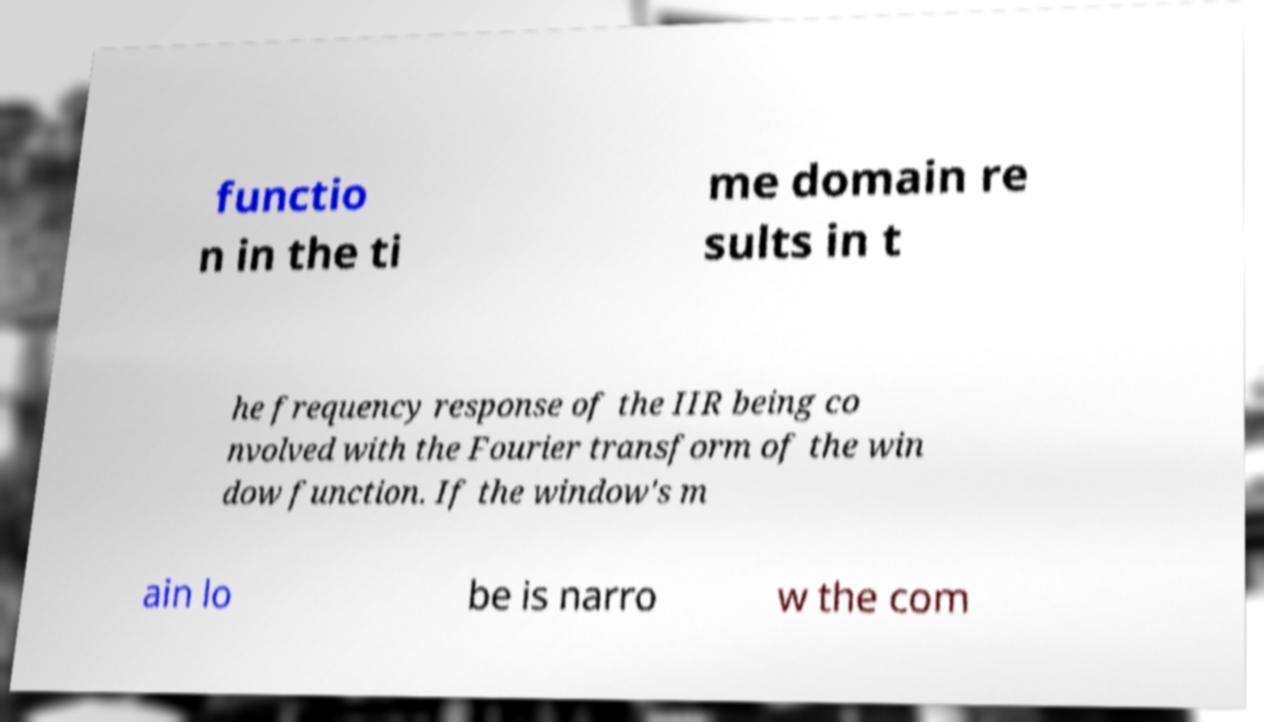Please read and relay the text visible in this image. What does it say? functio n in the ti me domain re sults in t he frequency response of the IIR being co nvolved with the Fourier transform of the win dow function. If the window's m ain lo be is narro w the com 